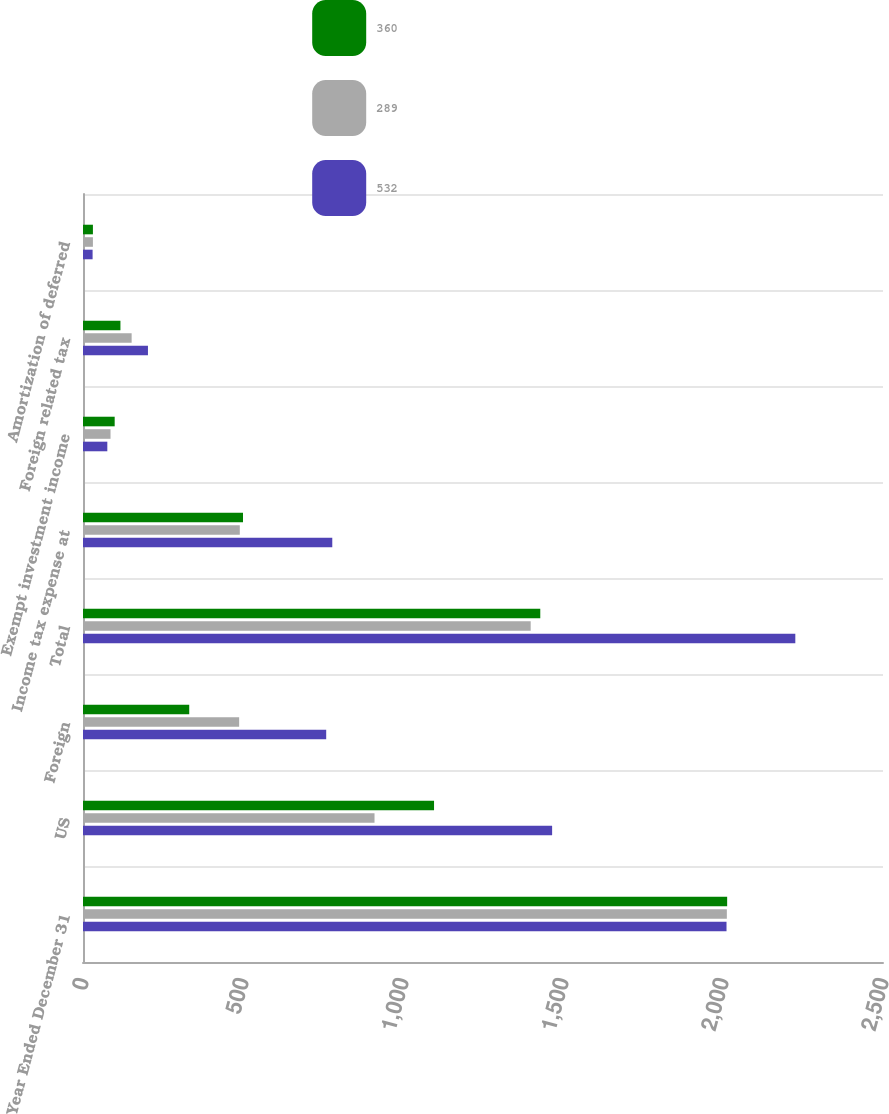Convert chart to OTSL. <chart><loc_0><loc_0><loc_500><loc_500><stacked_bar_chart><ecel><fcel>Year Ended December 31<fcel>US<fcel>Foreign<fcel>Total<fcel>Income tax expense at<fcel>Exempt investment income<fcel>Foreign related tax<fcel>Amortization of deferred<nl><fcel>360<fcel>2013<fcel>1097<fcel>332<fcel>1429<fcel>500<fcel>99<fcel>117<fcel>31<nl><fcel>289<fcel>2012<fcel>911<fcel>488<fcel>1399<fcel>490<fcel>86<fcel>152<fcel>31<nl><fcel>532<fcel>2011<fcel>1466<fcel>760<fcel>2226<fcel>779<fcel>76<fcel>203<fcel>30<nl></chart> 